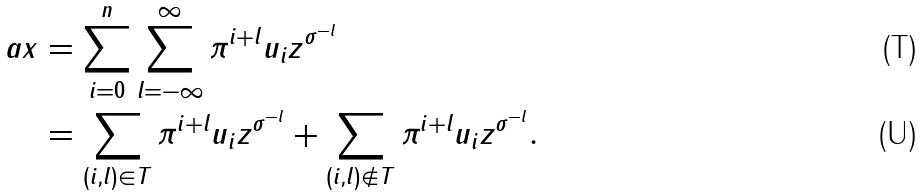<formula> <loc_0><loc_0><loc_500><loc_500>a x & = \sum _ { i = 0 } ^ { n } \sum _ { l = - \infty } ^ { \infty } \pi ^ { i + l } u _ { i } z ^ { \sigma ^ { - l } } \\ & = \sum _ { ( i , l ) \in T } \pi ^ { i + l } u _ { i } z ^ { \sigma ^ { - l } } + \sum _ { ( i , l ) \notin T } \pi ^ { i + l } u _ { i } z ^ { \sigma ^ { - l } } .</formula> 